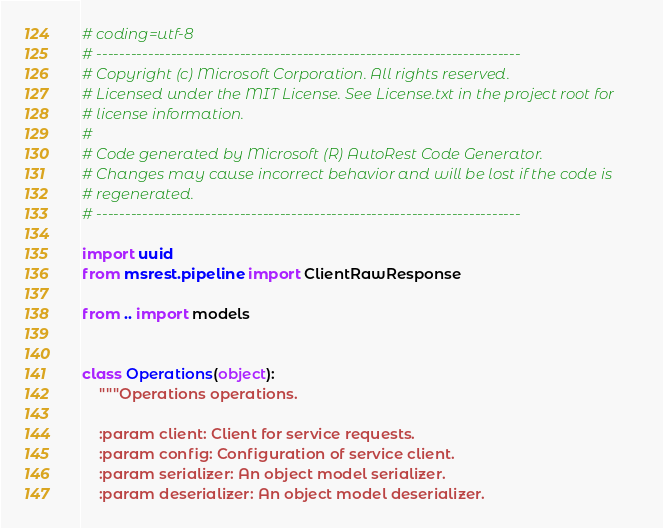Convert code to text. <code><loc_0><loc_0><loc_500><loc_500><_Python_># coding=utf-8
# --------------------------------------------------------------------------
# Copyright (c) Microsoft Corporation. All rights reserved.
# Licensed under the MIT License. See License.txt in the project root for
# license information.
#
# Code generated by Microsoft (R) AutoRest Code Generator.
# Changes may cause incorrect behavior and will be lost if the code is
# regenerated.
# --------------------------------------------------------------------------

import uuid
from msrest.pipeline import ClientRawResponse

from .. import models


class Operations(object):
    """Operations operations.

    :param client: Client for service requests.
    :param config: Configuration of service client.
    :param serializer: An object model serializer.
    :param deserializer: An object model deserializer.</code> 